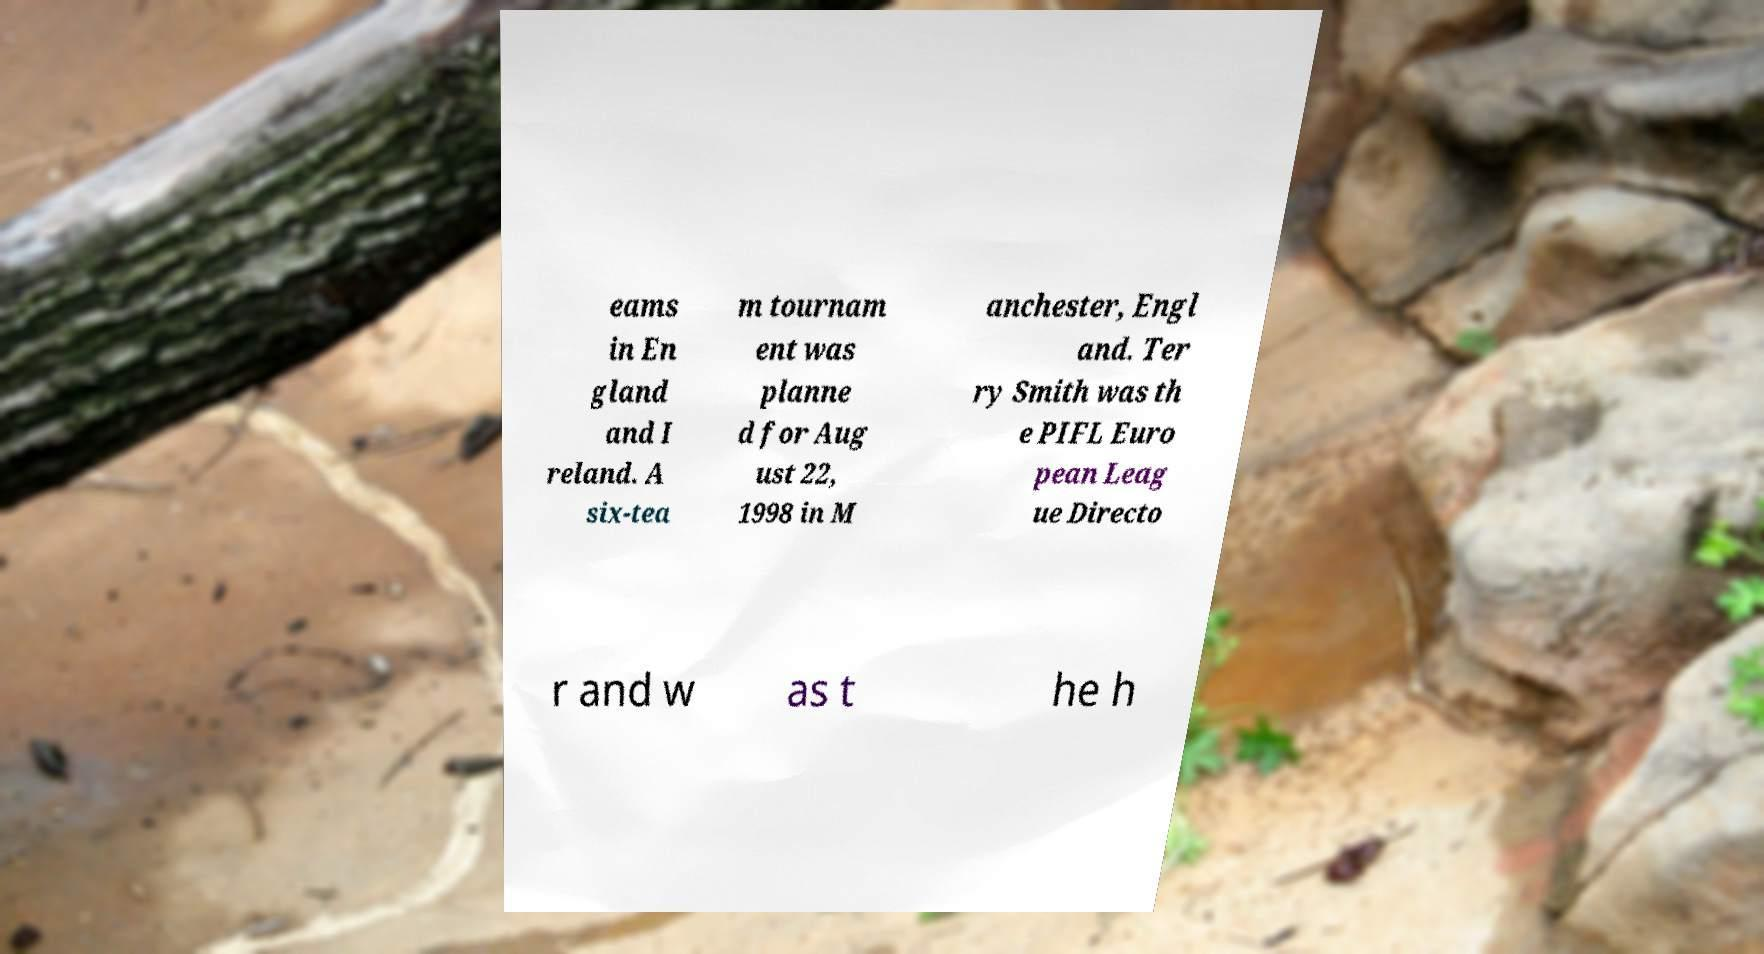Can you read and provide the text displayed in the image?This photo seems to have some interesting text. Can you extract and type it out for me? eams in En gland and I reland. A six-tea m tournam ent was planne d for Aug ust 22, 1998 in M anchester, Engl and. Ter ry Smith was th e PIFL Euro pean Leag ue Directo r and w as t he h 